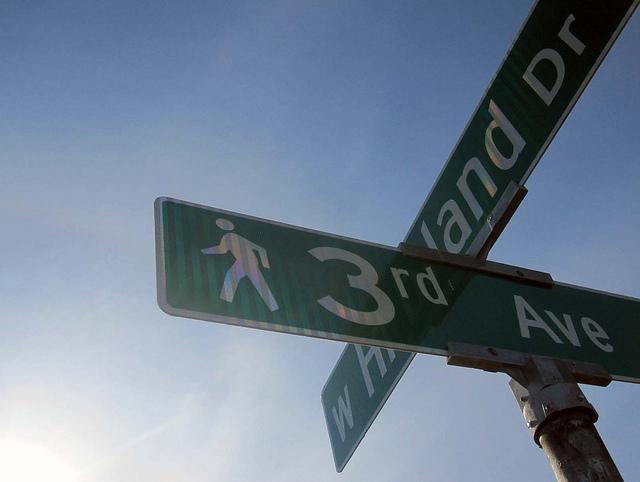Do all of the signs match?
Quick response, please. No. What time of day is this?
Be succinct. Afternoon. What cross streets are we at?
Concise answer only. 3rd and highland. What picture is on the signs?
Write a very short answer. Person walking. What city is this intersection in?
Be succinct. Highland. Is the paint reflective?
Quick response, please. Yes. 